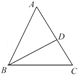Describe the process of constructing an angle bisector for angle A in triangle ABC. To construct an angle bisector for angle A, begin by placing the compass point at vertex A and drawing an arc that crosses both sides of the angle, let's say at points X and Y. Without adjusting the compass width, place the compass point at X and draw an arc inside the angle, and repeat the process from Y. The point where these two new arcs intersect, which we can label as D, forms the angle bisector AD of angle A. Drawing a straight line from A through D will precisely bisect angle A. 